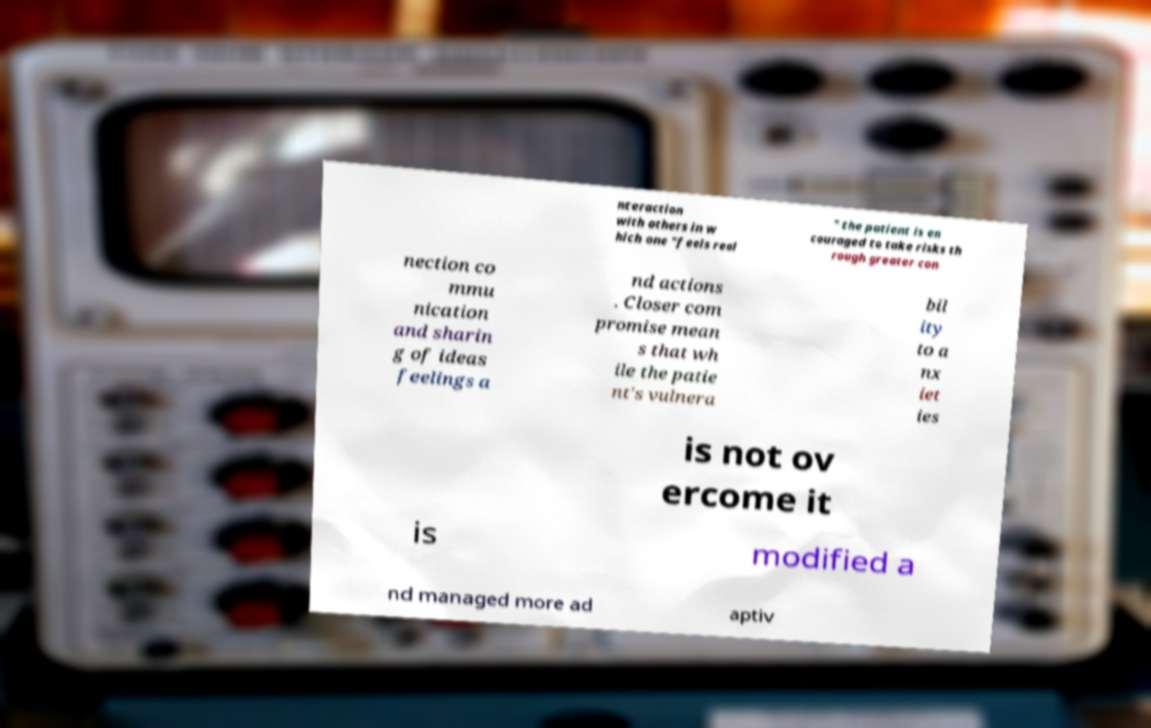Please identify and transcribe the text found in this image. nteraction with others in w hich one "feels real " the patient is en couraged to take risks th rough greater con nection co mmu nication and sharin g of ideas feelings a nd actions . Closer com promise mean s that wh ile the patie nt's vulnera bil ity to a nx iet ies is not ov ercome it is modified a nd managed more ad aptiv 